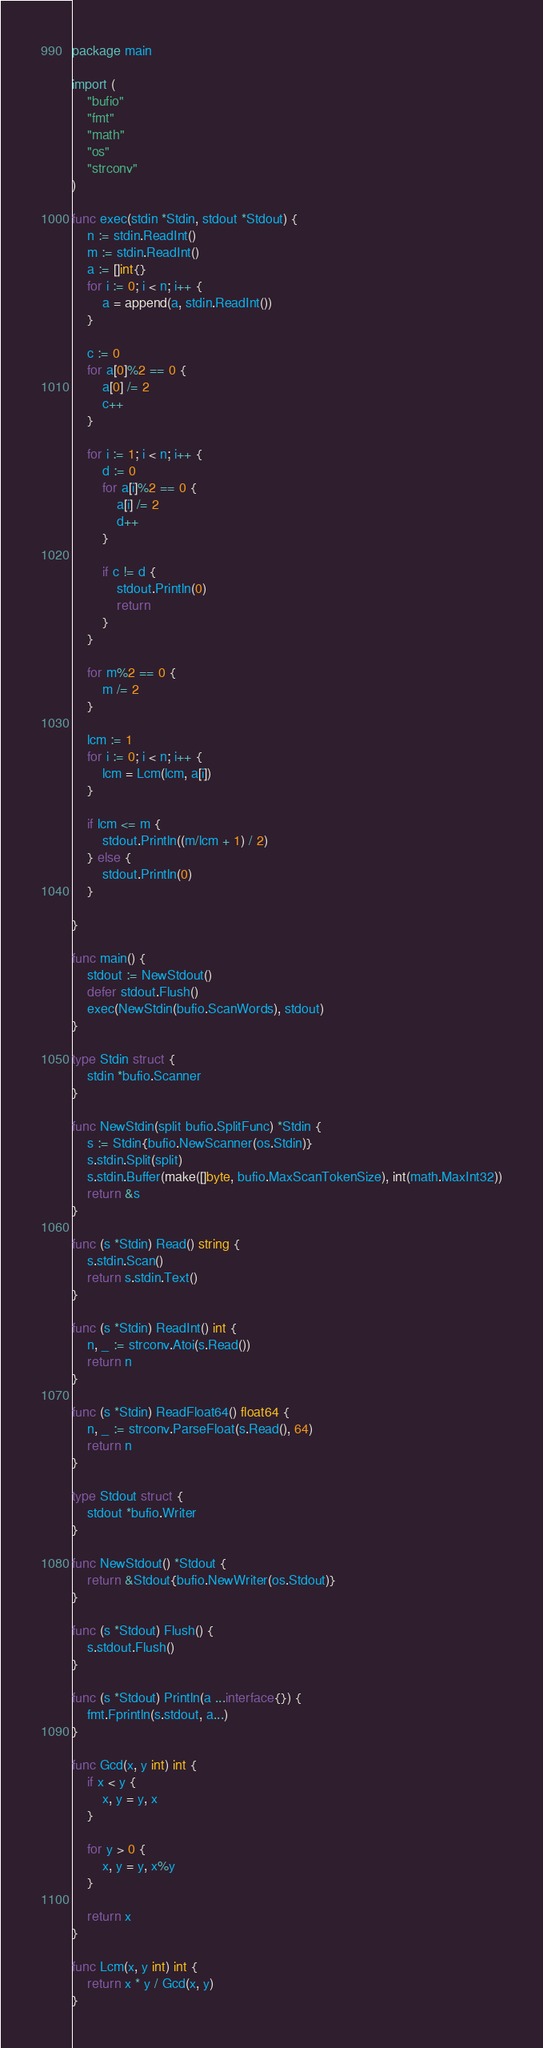Convert code to text. <code><loc_0><loc_0><loc_500><loc_500><_Go_>package main

import (
	"bufio"
	"fmt"
	"math"
	"os"
	"strconv"
)

func exec(stdin *Stdin, stdout *Stdout) {
	n := stdin.ReadInt()
	m := stdin.ReadInt()
	a := []int{}
	for i := 0; i < n; i++ {
		a = append(a, stdin.ReadInt())
	}

	c := 0
	for a[0]%2 == 0 {
		a[0] /= 2
		c++
	}

	for i := 1; i < n; i++ {
		d := 0
		for a[i]%2 == 0 {
			a[i] /= 2
			d++
		}

		if c != d {
			stdout.Println(0)
			return
		}
	}

	for m%2 == 0 {
		m /= 2
	}

	lcm := 1
	for i := 0; i < n; i++ {
		lcm = Lcm(lcm, a[i])
	}

	if lcm <= m {
		stdout.Println((m/lcm + 1) / 2)
	} else {
		stdout.Println(0)
	}

}

func main() {
	stdout := NewStdout()
	defer stdout.Flush()
	exec(NewStdin(bufio.ScanWords), stdout)
}

type Stdin struct {
	stdin *bufio.Scanner
}

func NewStdin(split bufio.SplitFunc) *Stdin {
	s := Stdin{bufio.NewScanner(os.Stdin)}
	s.stdin.Split(split)
	s.stdin.Buffer(make([]byte, bufio.MaxScanTokenSize), int(math.MaxInt32))
	return &s
}

func (s *Stdin) Read() string {
	s.stdin.Scan()
	return s.stdin.Text()
}

func (s *Stdin) ReadInt() int {
	n, _ := strconv.Atoi(s.Read())
	return n
}

func (s *Stdin) ReadFloat64() float64 {
	n, _ := strconv.ParseFloat(s.Read(), 64)
	return n
}

type Stdout struct {
	stdout *bufio.Writer
}

func NewStdout() *Stdout {
	return &Stdout{bufio.NewWriter(os.Stdout)}
}

func (s *Stdout) Flush() {
	s.stdout.Flush()
}

func (s *Stdout) Println(a ...interface{}) {
	fmt.Fprintln(s.stdout, a...)
}

func Gcd(x, y int) int {
	if x < y {
		x, y = y, x
	}

	for y > 0 {
		x, y = y, x%y
	}

	return x
}

func Lcm(x, y int) int {
	return x * y / Gcd(x, y)
}
</code> 